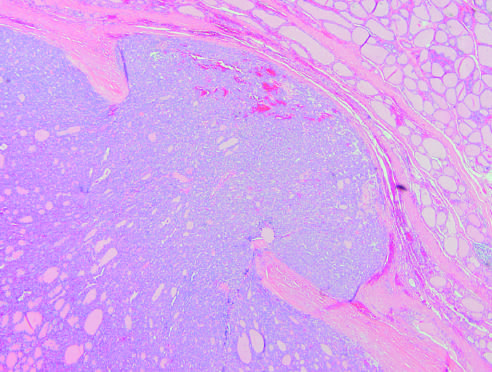do follicular carcinomas demonstrate capsular invasion that may be minimal, as in this case, or widespread, with extension into local structures of the neck by contrast?
Answer the question using a single word or phrase. Yes 